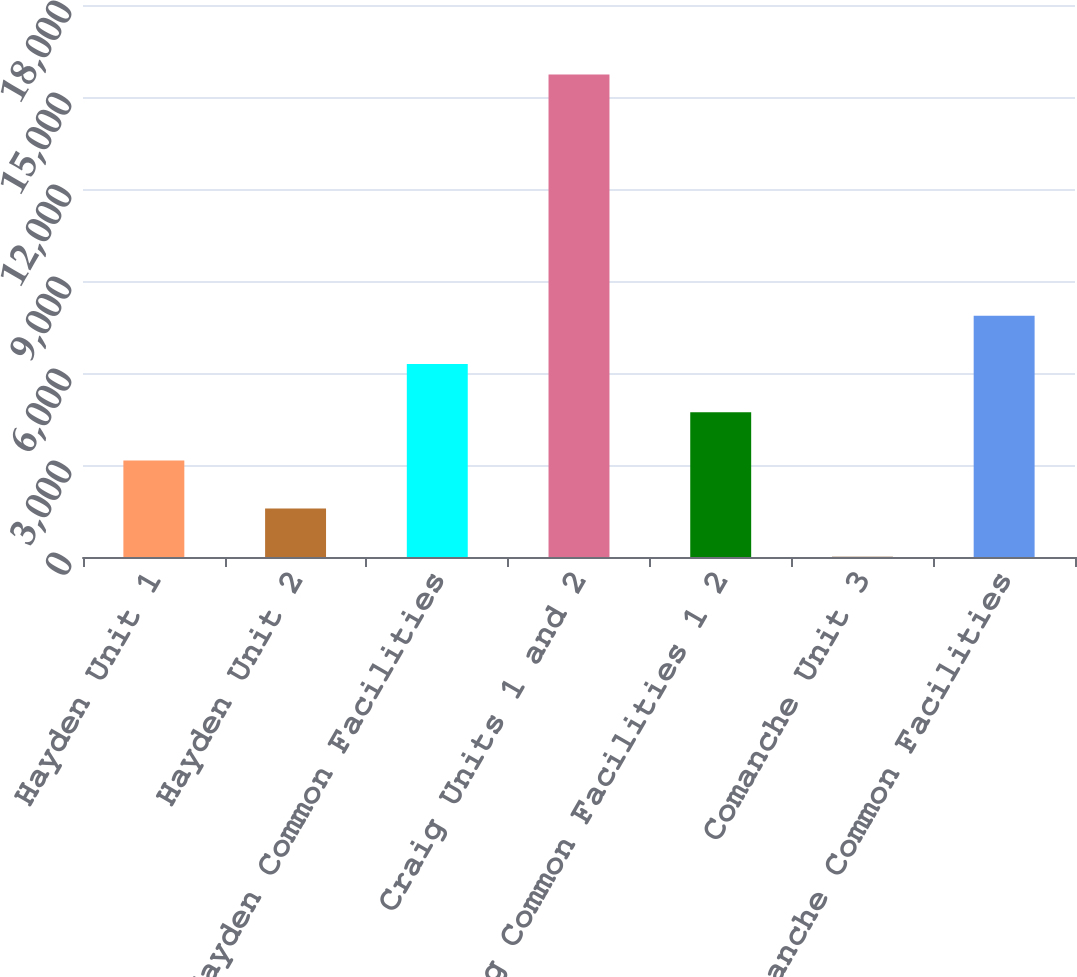Convert chart. <chart><loc_0><loc_0><loc_500><loc_500><bar_chart><fcel>Hayden Unit 1<fcel>Hayden Unit 2<fcel>Hayden Common Facilities<fcel>Craig Units 1 and 2<fcel>Craig Common Facilities 1 2<fcel>Comanche Unit 3<fcel>Comanche Common Facilities<nl><fcel>3150.8<fcel>1578.4<fcel>6295.6<fcel>15730<fcel>4723.2<fcel>6<fcel>7868<nl></chart> 